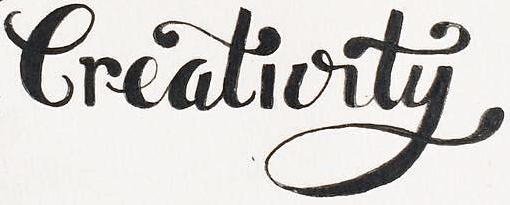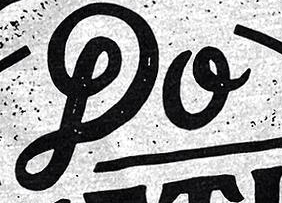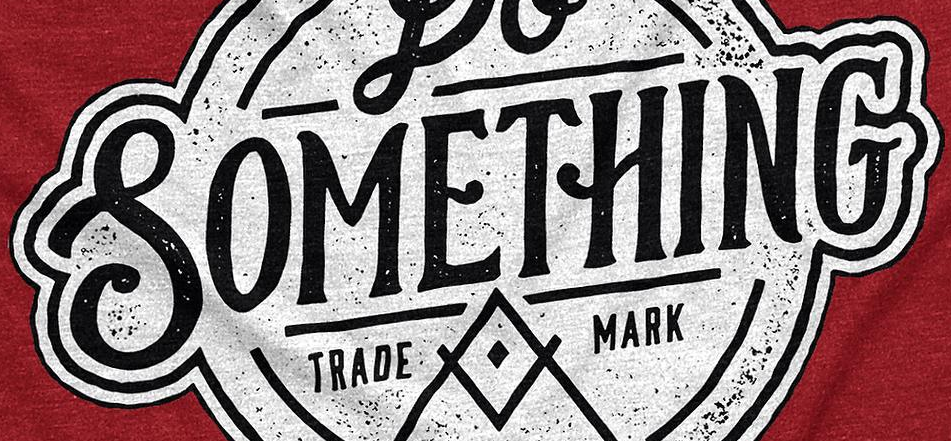What words can you see in these images in sequence, separated by a semicolon? Creativity; DO; SOMETHING 